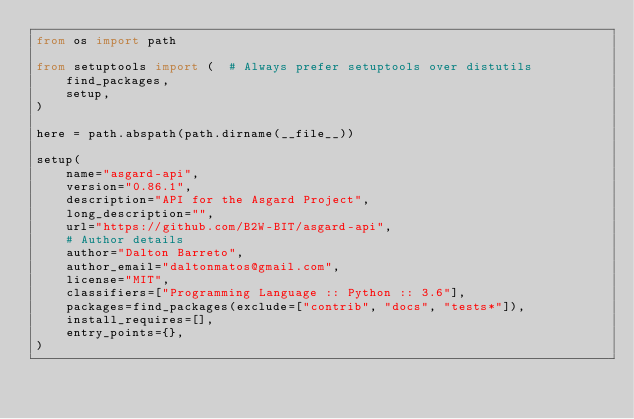<code> <loc_0><loc_0><loc_500><loc_500><_Python_>from os import path

from setuptools import (  # Always prefer setuptools over distutils
    find_packages,
    setup,
)

here = path.abspath(path.dirname(__file__))

setup(
    name="asgard-api",
    version="0.86.1",
    description="API for the Asgard Project",
    long_description="",
    url="https://github.com/B2W-BIT/asgard-api",
    # Author details
    author="Dalton Barreto",
    author_email="daltonmatos@gmail.com",
    license="MIT",
    classifiers=["Programming Language :: Python :: 3.6"],
    packages=find_packages(exclude=["contrib", "docs", "tests*"]),
    install_requires=[],
    entry_points={},
)
</code> 